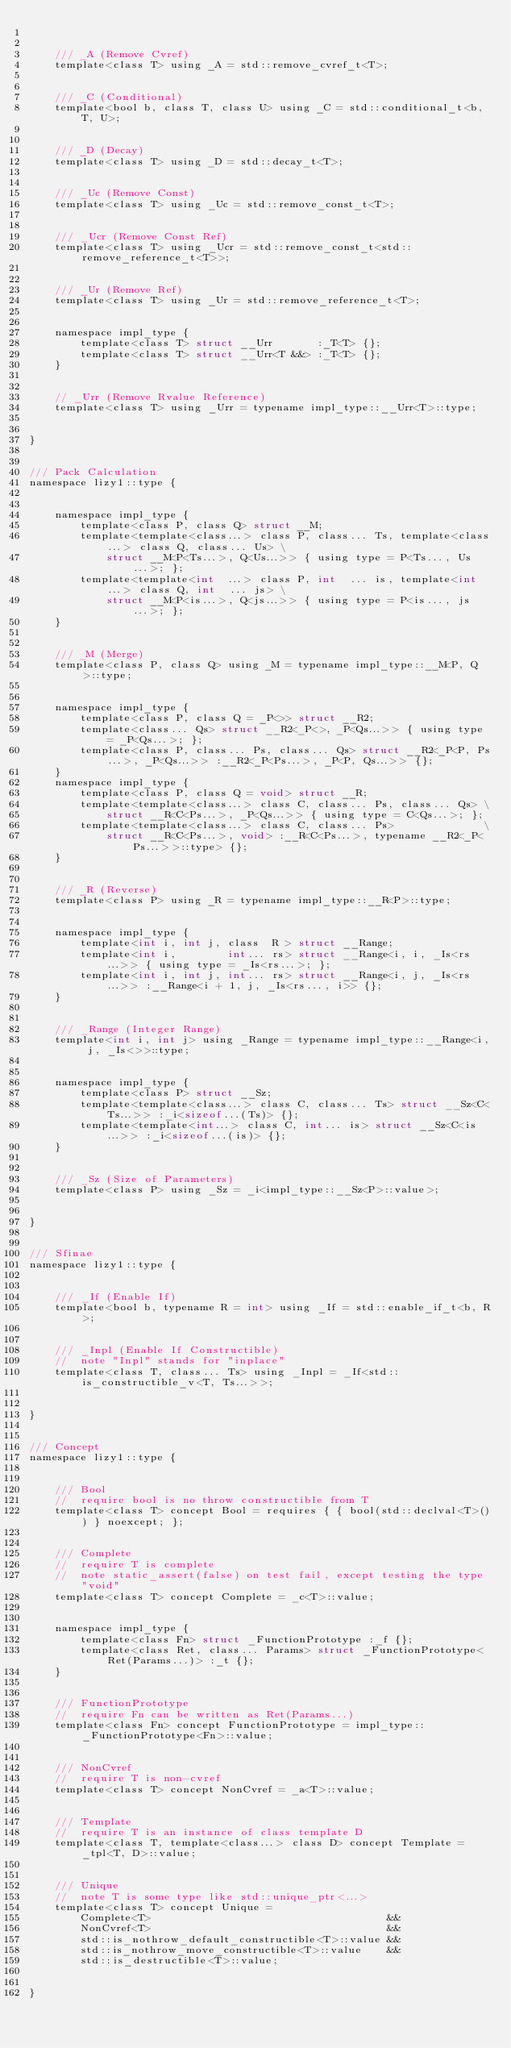<code> <loc_0><loc_0><loc_500><loc_500><_C_>

    /// _A (Remove Cvref)
    template<class T> using _A = std::remove_cvref_t<T>;


    /// _C (Conditional)
    template<bool b, class T, class U> using _C = std::conditional_t<b, T, U>;


    /// _D (Decay)
    template<class T> using _D = std::decay_t<T>;


    /// _Uc (Remove Const)
    template<class T> using _Uc = std::remove_const_t<T>;


    /// _Ucr (Remove Const Ref)
    template<class T> using _Ucr = std::remove_const_t<std::remove_reference_t<T>>;


    /// _Ur (Remove Ref)
    template<class T> using _Ur = std::remove_reference_t<T>;


    namespace impl_type {
        template<class T> struct __Urr       :_T<T> {};
        template<class T> struct __Urr<T &&> :_T<T> {};
    }


    // _Urr (Remove Rvalue Reference)
    template<class T> using _Urr = typename impl_type::__Urr<T>::type;


}


/// Pack Calculation
namespace lizy1::type {


    namespace impl_type {
        template<class P, class Q> struct __M;
        template<template<class...> class P, class... Ts, template<class...> class Q, class... Us> \
            struct __M<P<Ts...>, Q<Us...>> { using type = P<Ts..., Us...>; };
        template<template<int  ...> class P, int  ... is, template<int  ...> class Q, int  ... js> \
            struct __M<P<is...>, Q<js...>> { using type = P<is..., js...>; };
    }


    /// _M (Merge)
    template<class P, class Q> using _M = typename impl_type::__M<P, Q>::type;


    namespace impl_type {
        template<class P, class Q = _P<>> struct __R2;
        template<class... Qs> struct __R2<_P<>, _P<Qs...>> { using type = _P<Qs...>; };
        template<class P, class... Ps, class... Qs> struct __R2<_P<P, Ps...>, _P<Qs...>> :__R2<_P<Ps...>, _P<P, Qs...>> {};
    }
    namespace impl_type {
        template<class P, class Q = void> struct __R;
        template<template<class...> class C, class... Ps, class... Qs> \
            struct __R<C<Ps...>, _P<Qs...>> { using type = C<Qs...>; };
        template<template<class...> class C, class... Ps>              \
            struct __R<C<Ps...>, void> :__R<C<Ps...>, typename __R2<_P<Ps...>>::type> {};
    }


    /// _R (Reverse)
    template<class P> using _R = typename impl_type::__R<P>::type;


    namespace impl_type {
        template<int i, int j, class  R > struct __Range;
        template<int i,        int... rs> struct __Range<i, i, _Is<rs...>> { using type = _Is<rs...>; };
        template<int i, int j, int... rs> struct __Range<i, j, _Is<rs...>> :__Range<i + 1, j, _Is<rs..., i>> {};
    }


    /// _Range (Integer Range)
    template<int i, int j> using _Range = typename impl_type::__Range<i, j, _Is<>>::type;


    namespace impl_type {
        template<class P> struct __Sz;
        template<template<class...> class C, class... Ts> struct __Sz<C<Ts...>> :_i<sizeof...(Ts)> {};
        template<template<int...> class C, int... is> struct __Sz<C<is...>> :_i<sizeof...(is)> {};
    }


    /// _Sz (Size of Parameters)
    template<class P> using _Sz = _i<impl_type::__Sz<P>::value>;


}


/// Sfinae
namespace lizy1::type {


    /// _If (Enable If)
    template<bool b, typename R = int> using _If = std::enable_if_t<b, R>;


    /// _Inpl (Enable If Constructible)
    //  note "Inpl" stands for "inplace"
    template<class T, class... Ts> using _Inpl = _If<std::is_constructible_v<T, Ts...>>;


}


/// Concept
namespace lizy1::type {


    /// Bool
    //  require bool is no throw constructible from T
    template<class T> concept Bool = requires { { bool(std::declval<T>()) } noexcept; };


    /// Complete
    //  require T is complete
    //  note static_assert(false) on test fail, except testing the type "void"
    template<class T> concept Complete = _c<T>::value;


    namespace impl_type {
        template<class Fn> struct _FunctionPrototype :_f {};
        template<class Ret, class... Params> struct _FunctionPrototype<Ret(Params...)> :_t {};
    }


    /// FunctionPrototype
    //  require Fn can be written as Ret(Params...)
    template<class Fn> concept FunctionPrototype = impl_type::_FunctionPrototype<Fn>::value;


    /// NonCvref
    //  require T is non-cvref
    template<class T> concept NonCvref = _a<T>::value;


    /// Template
    //  require T is an instance of class template D
    template<class T, template<class...> class D> concept Template = _tpl<T, D>::value;


    /// Unique
    //  note T is some type like std::unique_ptr<...>
    template<class T> concept Unique =
        Complete<T>                                     &&
        NonCvref<T>                                     &&
        std::is_nothrow_default_constructible<T>::value &&
        std::is_nothrow_move_constructible<T>::value    &&
        std::is_destructible<T>::value;


}
</code> 